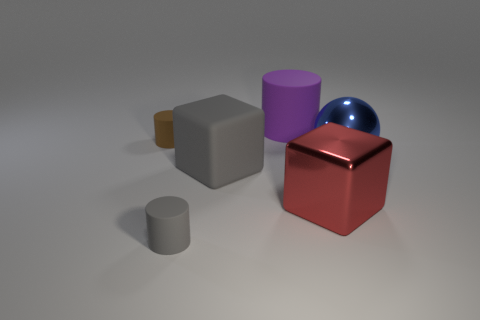Subtract all tiny cylinders. How many cylinders are left? 1 Subtract all red cubes. How many cubes are left? 1 Subtract 1 balls. How many balls are left? 0 Subtract all balls. How many objects are left? 5 Subtract all purple matte spheres. Subtract all small brown matte cylinders. How many objects are left? 5 Add 2 cubes. How many cubes are left? 4 Add 1 large cyan metallic objects. How many large cyan metallic objects exist? 1 Add 1 purple metallic cylinders. How many objects exist? 7 Subtract 1 red cubes. How many objects are left? 5 Subtract all green cylinders. Subtract all red cubes. How many cylinders are left? 3 